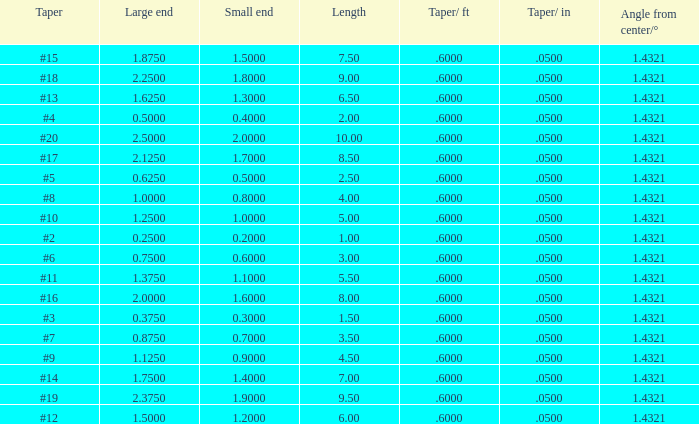Which Length has a Taper of #15, and a Large end larger than 1.875? None. 